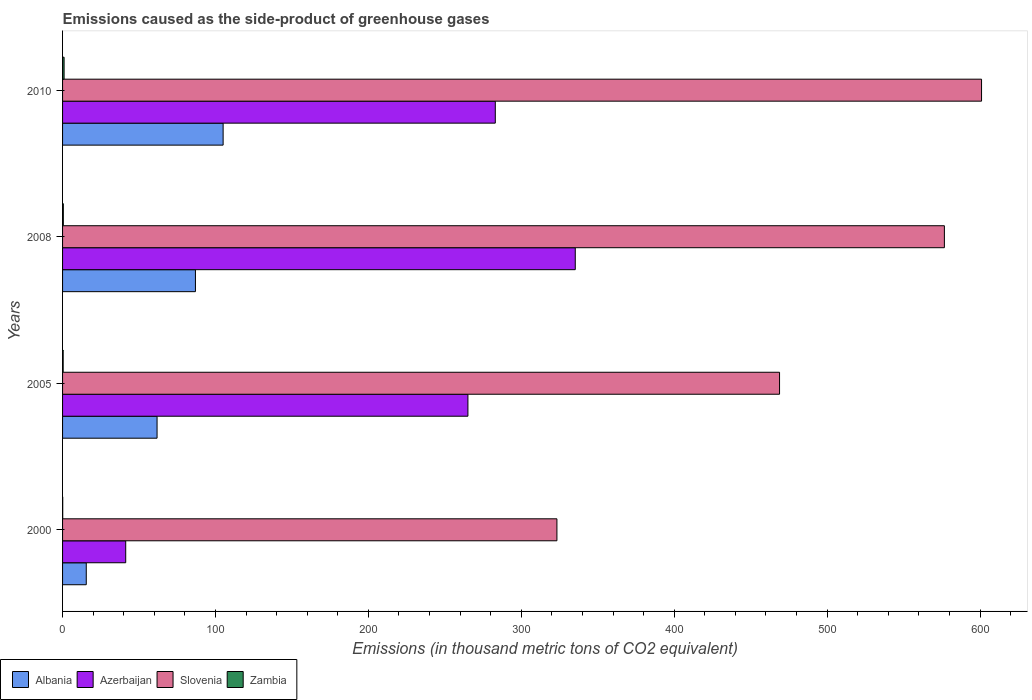How many different coloured bars are there?
Provide a short and direct response. 4. Are the number of bars per tick equal to the number of legend labels?
Give a very brief answer. Yes. How many bars are there on the 4th tick from the bottom?
Your response must be concise. 4. What is the label of the 4th group of bars from the top?
Provide a short and direct response. 2000. In how many cases, is the number of bars for a given year not equal to the number of legend labels?
Offer a very short reply. 0. What is the emissions caused as the side-product of greenhouse gases in Albania in 2008?
Ensure brevity in your answer.  86.9. Across all years, what is the maximum emissions caused as the side-product of greenhouse gases in Azerbaijan?
Provide a short and direct response. 335.3. Across all years, what is the minimum emissions caused as the side-product of greenhouse gases in Zambia?
Provide a short and direct response. 0.1. What is the total emissions caused as the side-product of greenhouse gases in Slovenia in the graph?
Your answer should be compact. 1969.9. What is the difference between the emissions caused as the side-product of greenhouse gases in Albania in 2008 and that in 2010?
Ensure brevity in your answer.  -18.1. What is the difference between the emissions caused as the side-product of greenhouse gases in Albania in 2005 and the emissions caused as the side-product of greenhouse gases in Slovenia in 2000?
Provide a succinct answer. -261.5. What is the average emissions caused as the side-product of greenhouse gases in Azerbaijan per year?
Keep it short and to the point. 231.18. In the year 2005, what is the difference between the emissions caused as the side-product of greenhouse gases in Zambia and emissions caused as the side-product of greenhouse gases in Slovenia?
Provide a succinct answer. -468.5. In how many years, is the emissions caused as the side-product of greenhouse gases in Zambia greater than 400 thousand metric tons?
Give a very brief answer. 0. What is the ratio of the emissions caused as the side-product of greenhouse gases in Zambia in 2000 to that in 2008?
Give a very brief answer. 0.2. Is the emissions caused as the side-product of greenhouse gases in Albania in 2005 less than that in 2008?
Ensure brevity in your answer.  Yes. What is the difference between the highest and the second highest emissions caused as the side-product of greenhouse gases in Albania?
Provide a succinct answer. 18.1. What is the difference between the highest and the lowest emissions caused as the side-product of greenhouse gases in Azerbaijan?
Your answer should be very brief. 294. In how many years, is the emissions caused as the side-product of greenhouse gases in Slovenia greater than the average emissions caused as the side-product of greenhouse gases in Slovenia taken over all years?
Ensure brevity in your answer.  2. Is the sum of the emissions caused as the side-product of greenhouse gases in Azerbaijan in 2005 and 2010 greater than the maximum emissions caused as the side-product of greenhouse gases in Albania across all years?
Your response must be concise. Yes. What does the 4th bar from the top in 2005 represents?
Your answer should be compact. Albania. What does the 2nd bar from the bottom in 2005 represents?
Give a very brief answer. Azerbaijan. How many bars are there?
Offer a very short reply. 16. Are all the bars in the graph horizontal?
Offer a terse response. Yes. What is the difference between two consecutive major ticks on the X-axis?
Your response must be concise. 100. Does the graph contain any zero values?
Ensure brevity in your answer.  No. How many legend labels are there?
Offer a very short reply. 4. How are the legend labels stacked?
Make the answer very short. Horizontal. What is the title of the graph?
Provide a succinct answer. Emissions caused as the side-product of greenhouse gases. What is the label or title of the X-axis?
Give a very brief answer. Emissions (in thousand metric tons of CO2 equivalent). What is the Emissions (in thousand metric tons of CO2 equivalent) in Azerbaijan in 2000?
Ensure brevity in your answer.  41.3. What is the Emissions (in thousand metric tons of CO2 equivalent) in Slovenia in 2000?
Your response must be concise. 323.3. What is the Emissions (in thousand metric tons of CO2 equivalent) of Zambia in 2000?
Ensure brevity in your answer.  0.1. What is the Emissions (in thousand metric tons of CO2 equivalent) of Albania in 2005?
Ensure brevity in your answer.  61.8. What is the Emissions (in thousand metric tons of CO2 equivalent) of Azerbaijan in 2005?
Ensure brevity in your answer.  265.1. What is the Emissions (in thousand metric tons of CO2 equivalent) of Slovenia in 2005?
Your answer should be very brief. 468.9. What is the Emissions (in thousand metric tons of CO2 equivalent) in Zambia in 2005?
Your response must be concise. 0.4. What is the Emissions (in thousand metric tons of CO2 equivalent) in Albania in 2008?
Your answer should be very brief. 86.9. What is the Emissions (in thousand metric tons of CO2 equivalent) in Azerbaijan in 2008?
Offer a terse response. 335.3. What is the Emissions (in thousand metric tons of CO2 equivalent) of Slovenia in 2008?
Your answer should be compact. 576.7. What is the Emissions (in thousand metric tons of CO2 equivalent) in Zambia in 2008?
Keep it short and to the point. 0.5. What is the Emissions (in thousand metric tons of CO2 equivalent) in Albania in 2010?
Offer a very short reply. 105. What is the Emissions (in thousand metric tons of CO2 equivalent) in Azerbaijan in 2010?
Keep it short and to the point. 283. What is the Emissions (in thousand metric tons of CO2 equivalent) in Slovenia in 2010?
Offer a terse response. 601. Across all years, what is the maximum Emissions (in thousand metric tons of CO2 equivalent) of Albania?
Your answer should be very brief. 105. Across all years, what is the maximum Emissions (in thousand metric tons of CO2 equivalent) in Azerbaijan?
Give a very brief answer. 335.3. Across all years, what is the maximum Emissions (in thousand metric tons of CO2 equivalent) in Slovenia?
Provide a succinct answer. 601. Across all years, what is the maximum Emissions (in thousand metric tons of CO2 equivalent) in Zambia?
Your answer should be compact. 1. Across all years, what is the minimum Emissions (in thousand metric tons of CO2 equivalent) of Albania?
Your answer should be compact. 15.5. Across all years, what is the minimum Emissions (in thousand metric tons of CO2 equivalent) in Azerbaijan?
Your answer should be very brief. 41.3. Across all years, what is the minimum Emissions (in thousand metric tons of CO2 equivalent) of Slovenia?
Ensure brevity in your answer.  323.3. Across all years, what is the minimum Emissions (in thousand metric tons of CO2 equivalent) in Zambia?
Provide a succinct answer. 0.1. What is the total Emissions (in thousand metric tons of CO2 equivalent) of Albania in the graph?
Make the answer very short. 269.2. What is the total Emissions (in thousand metric tons of CO2 equivalent) of Azerbaijan in the graph?
Make the answer very short. 924.7. What is the total Emissions (in thousand metric tons of CO2 equivalent) of Slovenia in the graph?
Your answer should be compact. 1969.9. What is the total Emissions (in thousand metric tons of CO2 equivalent) of Zambia in the graph?
Keep it short and to the point. 2. What is the difference between the Emissions (in thousand metric tons of CO2 equivalent) in Albania in 2000 and that in 2005?
Your response must be concise. -46.3. What is the difference between the Emissions (in thousand metric tons of CO2 equivalent) of Azerbaijan in 2000 and that in 2005?
Ensure brevity in your answer.  -223.8. What is the difference between the Emissions (in thousand metric tons of CO2 equivalent) in Slovenia in 2000 and that in 2005?
Your answer should be compact. -145.6. What is the difference between the Emissions (in thousand metric tons of CO2 equivalent) of Albania in 2000 and that in 2008?
Make the answer very short. -71.4. What is the difference between the Emissions (in thousand metric tons of CO2 equivalent) in Azerbaijan in 2000 and that in 2008?
Offer a very short reply. -294. What is the difference between the Emissions (in thousand metric tons of CO2 equivalent) of Slovenia in 2000 and that in 2008?
Offer a very short reply. -253.4. What is the difference between the Emissions (in thousand metric tons of CO2 equivalent) of Zambia in 2000 and that in 2008?
Offer a very short reply. -0.4. What is the difference between the Emissions (in thousand metric tons of CO2 equivalent) of Albania in 2000 and that in 2010?
Your answer should be very brief. -89.5. What is the difference between the Emissions (in thousand metric tons of CO2 equivalent) of Azerbaijan in 2000 and that in 2010?
Offer a terse response. -241.7. What is the difference between the Emissions (in thousand metric tons of CO2 equivalent) in Slovenia in 2000 and that in 2010?
Provide a short and direct response. -277.7. What is the difference between the Emissions (in thousand metric tons of CO2 equivalent) of Zambia in 2000 and that in 2010?
Offer a terse response. -0.9. What is the difference between the Emissions (in thousand metric tons of CO2 equivalent) of Albania in 2005 and that in 2008?
Ensure brevity in your answer.  -25.1. What is the difference between the Emissions (in thousand metric tons of CO2 equivalent) in Azerbaijan in 2005 and that in 2008?
Your answer should be compact. -70.2. What is the difference between the Emissions (in thousand metric tons of CO2 equivalent) of Slovenia in 2005 and that in 2008?
Keep it short and to the point. -107.8. What is the difference between the Emissions (in thousand metric tons of CO2 equivalent) of Zambia in 2005 and that in 2008?
Make the answer very short. -0.1. What is the difference between the Emissions (in thousand metric tons of CO2 equivalent) of Albania in 2005 and that in 2010?
Offer a terse response. -43.2. What is the difference between the Emissions (in thousand metric tons of CO2 equivalent) in Azerbaijan in 2005 and that in 2010?
Your answer should be very brief. -17.9. What is the difference between the Emissions (in thousand metric tons of CO2 equivalent) in Slovenia in 2005 and that in 2010?
Keep it short and to the point. -132.1. What is the difference between the Emissions (in thousand metric tons of CO2 equivalent) in Albania in 2008 and that in 2010?
Your answer should be compact. -18.1. What is the difference between the Emissions (in thousand metric tons of CO2 equivalent) in Azerbaijan in 2008 and that in 2010?
Provide a short and direct response. 52.3. What is the difference between the Emissions (in thousand metric tons of CO2 equivalent) in Slovenia in 2008 and that in 2010?
Ensure brevity in your answer.  -24.3. What is the difference between the Emissions (in thousand metric tons of CO2 equivalent) of Zambia in 2008 and that in 2010?
Your answer should be very brief. -0.5. What is the difference between the Emissions (in thousand metric tons of CO2 equivalent) in Albania in 2000 and the Emissions (in thousand metric tons of CO2 equivalent) in Azerbaijan in 2005?
Your response must be concise. -249.6. What is the difference between the Emissions (in thousand metric tons of CO2 equivalent) in Albania in 2000 and the Emissions (in thousand metric tons of CO2 equivalent) in Slovenia in 2005?
Make the answer very short. -453.4. What is the difference between the Emissions (in thousand metric tons of CO2 equivalent) of Azerbaijan in 2000 and the Emissions (in thousand metric tons of CO2 equivalent) of Slovenia in 2005?
Provide a succinct answer. -427.6. What is the difference between the Emissions (in thousand metric tons of CO2 equivalent) of Azerbaijan in 2000 and the Emissions (in thousand metric tons of CO2 equivalent) of Zambia in 2005?
Make the answer very short. 40.9. What is the difference between the Emissions (in thousand metric tons of CO2 equivalent) in Slovenia in 2000 and the Emissions (in thousand metric tons of CO2 equivalent) in Zambia in 2005?
Offer a terse response. 322.9. What is the difference between the Emissions (in thousand metric tons of CO2 equivalent) in Albania in 2000 and the Emissions (in thousand metric tons of CO2 equivalent) in Azerbaijan in 2008?
Offer a terse response. -319.8. What is the difference between the Emissions (in thousand metric tons of CO2 equivalent) in Albania in 2000 and the Emissions (in thousand metric tons of CO2 equivalent) in Slovenia in 2008?
Offer a terse response. -561.2. What is the difference between the Emissions (in thousand metric tons of CO2 equivalent) of Albania in 2000 and the Emissions (in thousand metric tons of CO2 equivalent) of Zambia in 2008?
Make the answer very short. 15. What is the difference between the Emissions (in thousand metric tons of CO2 equivalent) of Azerbaijan in 2000 and the Emissions (in thousand metric tons of CO2 equivalent) of Slovenia in 2008?
Offer a very short reply. -535.4. What is the difference between the Emissions (in thousand metric tons of CO2 equivalent) in Azerbaijan in 2000 and the Emissions (in thousand metric tons of CO2 equivalent) in Zambia in 2008?
Make the answer very short. 40.8. What is the difference between the Emissions (in thousand metric tons of CO2 equivalent) of Slovenia in 2000 and the Emissions (in thousand metric tons of CO2 equivalent) of Zambia in 2008?
Your response must be concise. 322.8. What is the difference between the Emissions (in thousand metric tons of CO2 equivalent) of Albania in 2000 and the Emissions (in thousand metric tons of CO2 equivalent) of Azerbaijan in 2010?
Make the answer very short. -267.5. What is the difference between the Emissions (in thousand metric tons of CO2 equivalent) in Albania in 2000 and the Emissions (in thousand metric tons of CO2 equivalent) in Slovenia in 2010?
Make the answer very short. -585.5. What is the difference between the Emissions (in thousand metric tons of CO2 equivalent) of Albania in 2000 and the Emissions (in thousand metric tons of CO2 equivalent) of Zambia in 2010?
Your answer should be very brief. 14.5. What is the difference between the Emissions (in thousand metric tons of CO2 equivalent) in Azerbaijan in 2000 and the Emissions (in thousand metric tons of CO2 equivalent) in Slovenia in 2010?
Your answer should be very brief. -559.7. What is the difference between the Emissions (in thousand metric tons of CO2 equivalent) of Azerbaijan in 2000 and the Emissions (in thousand metric tons of CO2 equivalent) of Zambia in 2010?
Offer a terse response. 40.3. What is the difference between the Emissions (in thousand metric tons of CO2 equivalent) in Slovenia in 2000 and the Emissions (in thousand metric tons of CO2 equivalent) in Zambia in 2010?
Provide a succinct answer. 322.3. What is the difference between the Emissions (in thousand metric tons of CO2 equivalent) in Albania in 2005 and the Emissions (in thousand metric tons of CO2 equivalent) in Azerbaijan in 2008?
Your response must be concise. -273.5. What is the difference between the Emissions (in thousand metric tons of CO2 equivalent) in Albania in 2005 and the Emissions (in thousand metric tons of CO2 equivalent) in Slovenia in 2008?
Make the answer very short. -514.9. What is the difference between the Emissions (in thousand metric tons of CO2 equivalent) in Albania in 2005 and the Emissions (in thousand metric tons of CO2 equivalent) in Zambia in 2008?
Your answer should be very brief. 61.3. What is the difference between the Emissions (in thousand metric tons of CO2 equivalent) in Azerbaijan in 2005 and the Emissions (in thousand metric tons of CO2 equivalent) in Slovenia in 2008?
Your answer should be compact. -311.6. What is the difference between the Emissions (in thousand metric tons of CO2 equivalent) in Azerbaijan in 2005 and the Emissions (in thousand metric tons of CO2 equivalent) in Zambia in 2008?
Make the answer very short. 264.6. What is the difference between the Emissions (in thousand metric tons of CO2 equivalent) of Slovenia in 2005 and the Emissions (in thousand metric tons of CO2 equivalent) of Zambia in 2008?
Make the answer very short. 468.4. What is the difference between the Emissions (in thousand metric tons of CO2 equivalent) of Albania in 2005 and the Emissions (in thousand metric tons of CO2 equivalent) of Azerbaijan in 2010?
Provide a short and direct response. -221.2. What is the difference between the Emissions (in thousand metric tons of CO2 equivalent) in Albania in 2005 and the Emissions (in thousand metric tons of CO2 equivalent) in Slovenia in 2010?
Ensure brevity in your answer.  -539.2. What is the difference between the Emissions (in thousand metric tons of CO2 equivalent) of Albania in 2005 and the Emissions (in thousand metric tons of CO2 equivalent) of Zambia in 2010?
Ensure brevity in your answer.  60.8. What is the difference between the Emissions (in thousand metric tons of CO2 equivalent) in Azerbaijan in 2005 and the Emissions (in thousand metric tons of CO2 equivalent) in Slovenia in 2010?
Ensure brevity in your answer.  -335.9. What is the difference between the Emissions (in thousand metric tons of CO2 equivalent) of Azerbaijan in 2005 and the Emissions (in thousand metric tons of CO2 equivalent) of Zambia in 2010?
Provide a succinct answer. 264.1. What is the difference between the Emissions (in thousand metric tons of CO2 equivalent) in Slovenia in 2005 and the Emissions (in thousand metric tons of CO2 equivalent) in Zambia in 2010?
Your answer should be very brief. 467.9. What is the difference between the Emissions (in thousand metric tons of CO2 equivalent) of Albania in 2008 and the Emissions (in thousand metric tons of CO2 equivalent) of Azerbaijan in 2010?
Provide a succinct answer. -196.1. What is the difference between the Emissions (in thousand metric tons of CO2 equivalent) of Albania in 2008 and the Emissions (in thousand metric tons of CO2 equivalent) of Slovenia in 2010?
Your answer should be compact. -514.1. What is the difference between the Emissions (in thousand metric tons of CO2 equivalent) in Albania in 2008 and the Emissions (in thousand metric tons of CO2 equivalent) in Zambia in 2010?
Offer a very short reply. 85.9. What is the difference between the Emissions (in thousand metric tons of CO2 equivalent) of Azerbaijan in 2008 and the Emissions (in thousand metric tons of CO2 equivalent) of Slovenia in 2010?
Provide a succinct answer. -265.7. What is the difference between the Emissions (in thousand metric tons of CO2 equivalent) of Azerbaijan in 2008 and the Emissions (in thousand metric tons of CO2 equivalent) of Zambia in 2010?
Your answer should be compact. 334.3. What is the difference between the Emissions (in thousand metric tons of CO2 equivalent) in Slovenia in 2008 and the Emissions (in thousand metric tons of CO2 equivalent) in Zambia in 2010?
Ensure brevity in your answer.  575.7. What is the average Emissions (in thousand metric tons of CO2 equivalent) of Albania per year?
Ensure brevity in your answer.  67.3. What is the average Emissions (in thousand metric tons of CO2 equivalent) of Azerbaijan per year?
Keep it short and to the point. 231.18. What is the average Emissions (in thousand metric tons of CO2 equivalent) in Slovenia per year?
Ensure brevity in your answer.  492.48. What is the average Emissions (in thousand metric tons of CO2 equivalent) in Zambia per year?
Provide a succinct answer. 0.5. In the year 2000, what is the difference between the Emissions (in thousand metric tons of CO2 equivalent) in Albania and Emissions (in thousand metric tons of CO2 equivalent) in Azerbaijan?
Offer a very short reply. -25.8. In the year 2000, what is the difference between the Emissions (in thousand metric tons of CO2 equivalent) in Albania and Emissions (in thousand metric tons of CO2 equivalent) in Slovenia?
Your response must be concise. -307.8. In the year 2000, what is the difference between the Emissions (in thousand metric tons of CO2 equivalent) of Albania and Emissions (in thousand metric tons of CO2 equivalent) of Zambia?
Provide a succinct answer. 15.4. In the year 2000, what is the difference between the Emissions (in thousand metric tons of CO2 equivalent) of Azerbaijan and Emissions (in thousand metric tons of CO2 equivalent) of Slovenia?
Make the answer very short. -282. In the year 2000, what is the difference between the Emissions (in thousand metric tons of CO2 equivalent) of Azerbaijan and Emissions (in thousand metric tons of CO2 equivalent) of Zambia?
Provide a short and direct response. 41.2. In the year 2000, what is the difference between the Emissions (in thousand metric tons of CO2 equivalent) of Slovenia and Emissions (in thousand metric tons of CO2 equivalent) of Zambia?
Make the answer very short. 323.2. In the year 2005, what is the difference between the Emissions (in thousand metric tons of CO2 equivalent) in Albania and Emissions (in thousand metric tons of CO2 equivalent) in Azerbaijan?
Ensure brevity in your answer.  -203.3. In the year 2005, what is the difference between the Emissions (in thousand metric tons of CO2 equivalent) in Albania and Emissions (in thousand metric tons of CO2 equivalent) in Slovenia?
Your answer should be very brief. -407.1. In the year 2005, what is the difference between the Emissions (in thousand metric tons of CO2 equivalent) in Albania and Emissions (in thousand metric tons of CO2 equivalent) in Zambia?
Make the answer very short. 61.4. In the year 2005, what is the difference between the Emissions (in thousand metric tons of CO2 equivalent) in Azerbaijan and Emissions (in thousand metric tons of CO2 equivalent) in Slovenia?
Offer a very short reply. -203.8. In the year 2005, what is the difference between the Emissions (in thousand metric tons of CO2 equivalent) in Azerbaijan and Emissions (in thousand metric tons of CO2 equivalent) in Zambia?
Keep it short and to the point. 264.7. In the year 2005, what is the difference between the Emissions (in thousand metric tons of CO2 equivalent) in Slovenia and Emissions (in thousand metric tons of CO2 equivalent) in Zambia?
Your response must be concise. 468.5. In the year 2008, what is the difference between the Emissions (in thousand metric tons of CO2 equivalent) of Albania and Emissions (in thousand metric tons of CO2 equivalent) of Azerbaijan?
Give a very brief answer. -248.4. In the year 2008, what is the difference between the Emissions (in thousand metric tons of CO2 equivalent) in Albania and Emissions (in thousand metric tons of CO2 equivalent) in Slovenia?
Offer a terse response. -489.8. In the year 2008, what is the difference between the Emissions (in thousand metric tons of CO2 equivalent) in Albania and Emissions (in thousand metric tons of CO2 equivalent) in Zambia?
Give a very brief answer. 86.4. In the year 2008, what is the difference between the Emissions (in thousand metric tons of CO2 equivalent) of Azerbaijan and Emissions (in thousand metric tons of CO2 equivalent) of Slovenia?
Offer a very short reply. -241.4. In the year 2008, what is the difference between the Emissions (in thousand metric tons of CO2 equivalent) in Azerbaijan and Emissions (in thousand metric tons of CO2 equivalent) in Zambia?
Offer a very short reply. 334.8. In the year 2008, what is the difference between the Emissions (in thousand metric tons of CO2 equivalent) in Slovenia and Emissions (in thousand metric tons of CO2 equivalent) in Zambia?
Your answer should be very brief. 576.2. In the year 2010, what is the difference between the Emissions (in thousand metric tons of CO2 equivalent) of Albania and Emissions (in thousand metric tons of CO2 equivalent) of Azerbaijan?
Keep it short and to the point. -178. In the year 2010, what is the difference between the Emissions (in thousand metric tons of CO2 equivalent) of Albania and Emissions (in thousand metric tons of CO2 equivalent) of Slovenia?
Make the answer very short. -496. In the year 2010, what is the difference between the Emissions (in thousand metric tons of CO2 equivalent) of Albania and Emissions (in thousand metric tons of CO2 equivalent) of Zambia?
Offer a terse response. 104. In the year 2010, what is the difference between the Emissions (in thousand metric tons of CO2 equivalent) in Azerbaijan and Emissions (in thousand metric tons of CO2 equivalent) in Slovenia?
Provide a succinct answer. -318. In the year 2010, what is the difference between the Emissions (in thousand metric tons of CO2 equivalent) in Azerbaijan and Emissions (in thousand metric tons of CO2 equivalent) in Zambia?
Your response must be concise. 282. In the year 2010, what is the difference between the Emissions (in thousand metric tons of CO2 equivalent) in Slovenia and Emissions (in thousand metric tons of CO2 equivalent) in Zambia?
Make the answer very short. 600. What is the ratio of the Emissions (in thousand metric tons of CO2 equivalent) of Albania in 2000 to that in 2005?
Ensure brevity in your answer.  0.25. What is the ratio of the Emissions (in thousand metric tons of CO2 equivalent) of Azerbaijan in 2000 to that in 2005?
Offer a terse response. 0.16. What is the ratio of the Emissions (in thousand metric tons of CO2 equivalent) of Slovenia in 2000 to that in 2005?
Make the answer very short. 0.69. What is the ratio of the Emissions (in thousand metric tons of CO2 equivalent) in Zambia in 2000 to that in 2005?
Your answer should be very brief. 0.25. What is the ratio of the Emissions (in thousand metric tons of CO2 equivalent) of Albania in 2000 to that in 2008?
Your response must be concise. 0.18. What is the ratio of the Emissions (in thousand metric tons of CO2 equivalent) of Azerbaijan in 2000 to that in 2008?
Give a very brief answer. 0.12. What is the ratio of the Emissions (in thousand metric tons of CO2 equivalent) in Slovenia in 2000 to that in 2008?
Offer a terse response. 0.56. What is the ratio of the Emissions (in thousand metric tons of CO2 equivalent) in Albania in 2000 to that in 2010?
Your response must be concise. 0.15. What is the ratio of the Emissions (in thousand metric tons of CO2 equivalent) of Azerbaijan in 2000 to that in 2010?
Provide a short and direct response. 0.15. What is the ratio of the Emissions (in thousand metric tons of CO2 equivalent) in Slovenia in 2000 to that in 2010?
Offer a terse response. 0.54. What is the ratio of the Emissions (in thousand metric tons of CO2 equivalent) in Albania in 2005 to that in 2008?
Ensure brevity in your answer.  0.71. What is the ratio of the Emissions (in thousand metric tons of CO2 equivalent) in Azerbaijan in 2005 to that in 2008?
Offer a terse response. 0.79. What is the ratio of the Emissions (in thousand metric tons of CO2 equivalent) in Slovenia in 2005 to that in 2008?
Give a very brief answer. 0.81. What is the ratio of the Emissions (in thousand metric tons of CO2 equivalent) in Albania in 2005 to that in 2010?
Offer a very short reply. 0.59. What is the ratio of the Emissions (in thousand metric tons of CO2 equivalent) in Azerbaijan in 2005 to that in 2010?
Offer a terse response. 0.94. What is the ratio of the Emissions (in thousand metric tons of CO2 equivalent) in Slovenia in 2005 to that in 2010?
Offer a terse response. 0.78. What is the ratio of the Emissions (in thousand metric tons of CO2 equivalent) of Zambia in 2005 to that in 2010?
Offer a terse response. 0.4. What is the ratio of the Emissions (in thousand metric tons of CO2 equivalent) in Albania in 2008 to that in 2010?
Offer a terse response. 0.83. What is the ratio of the Emissions (in thousand metric tons of CO2 equivalent) in Azerbaijan in 2008 to that in 2010?
Your answer should be very brief. 1.18. What is the ratio of the Emissions (in thousand metric tons of CO2 equivalent) of Slovenia in 2008 to that in 2010?
Provide a short and direct response. 0.96. What is the ratio of the Emissions (in thousand metric tons of CO2 equivalent) in Zambia in 2008 to that in 2010?
Keep it short and to the point. 0.5. What is the difference between the highest and the second highest Emissions (in thousand metric tons of CO2 equivalent) of Albania?
Make the answer very short. 18.1. What is the difference between the highest and the second highest Emissions (in thousand metric tons of CO2 equivalent) in Azerbaijan?
Your answer should be very brief. 52.3. What is the difference between the highest and the second highest Emissions (in thousand metric tons of CO2 equivalent) of Slovenia?
Give a very brief answer. 24.3. What is the difference between the highest and the second highest Emissions (in thousand metric tons of CO2 equivalent) of Zambia?
Give a very brief answer. 0.5. What is the difference between the highest and the lowest Emissions (in thousand metric tons of CO2 equivalent) of Albania?
Give a very brief answer. 89.5. What is the difference between the highest and the lowest Emissions (in thousand metric tons of CO2 equivalent) of Azerbaijan?
Your answer should be very brief. 294. What is the difference between the highest and the lowest Emissions (in thousand metric tons of CO2 equivalent) in Slovenia?
Keep it short and to the point. 277.7. What is the difference between the highest and the lowest Emissions (in thousand metric tons of CO2 equivalent) of Zambia?
Offer a terse response. 0.9. 